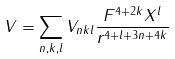Convert formula to latex. <formula><loc_0><loc_0><loc_500><loc_500>V = \sum _ { n , k , l } V _ { n k l } \frac { F ^ { 4 + 2 k } X ^ { l } } { r ^ { 4 + l + 3 n + 4 k } }</formula> 